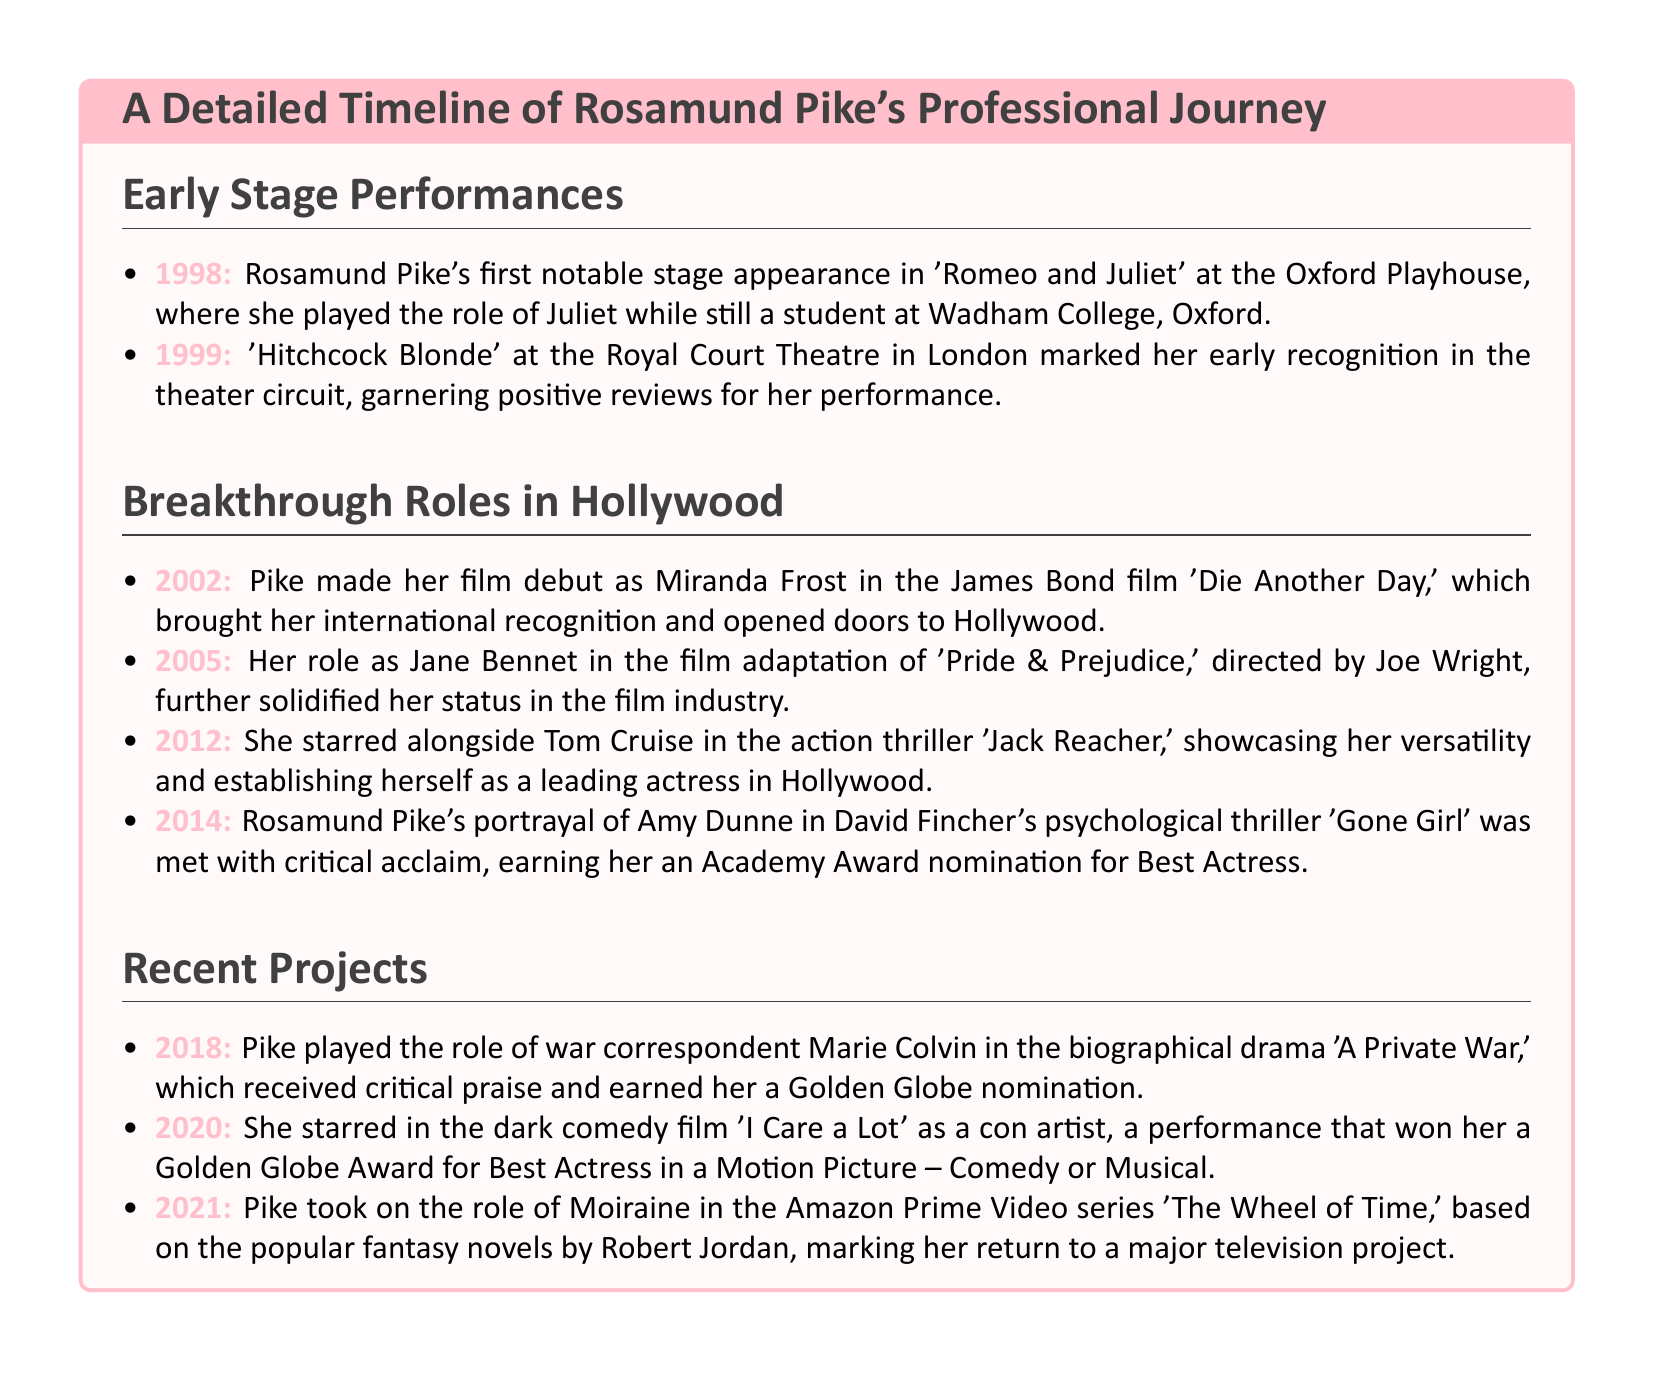What year did Rosamund Pike first appear in 'Romeo and Juliet'? The document states that she performed in 'Romeo and Juliet' in 1998 at the Oxford Playhouse.
Answer: 1998 Which character did Rosamund Pike play in 'Die Another Day'? The document mentions that she portrayed Miranda Frost in her film debut 'Die Another Day'.
Answer: Miranda Frost What film earned Rosamund Pike an Academy Award nomination? The document specifies that her role in 'Gone Girl' earned her an Academy Award nomination for Best Actress.
Answer: Gone Girl In what year did Rosamund Pike receive a Golden Globe nomination for 'A Private War'? The document notes that she received critical praise and a Golden Globe nomination for her role in 'A Private War' in 2018.
Answer: 2018 Who directed the film adaptation of 'Pride & Prejudice'? The document states that Joe Wright directed the film adaptation, in which Pike played Jane Bennet.
Answer: Joe Wright How many notable stage performances are mentioned in the document? The document lists two notable stage performances by Rosamund Pike in its Early Stage Performances section.
Answer: Two Which series marked Rosamund Pike's return to a major television project? The document states that she took on the role of Moiraine in 'The Wheel of Time', marking her return to television.
Answer: The Wheel of Time What was Rosamund Pike's role in 'I Care a Lot'? According to the document, she starred as a con artist in the dark comedy film 'I Care a Lot'.
Answer: Con artist What year did Rosamund Pike star alongside Tom Cruise? The document mentions that she starred alongside Tom Cruise in 'Jack Reacher' in 2012.
Answer: 2012 